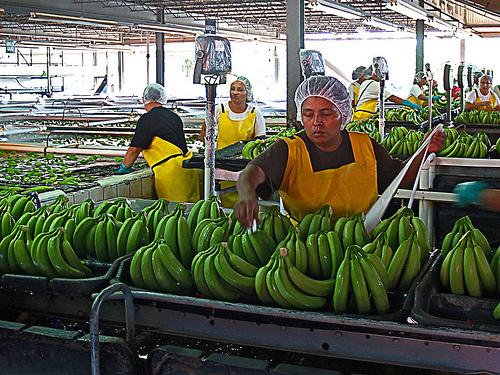Question: where was this picture taken?
Choices:
A. An apple orchard.
B. A winery.
C. A banana farm.
D. A theme park.
Answer with the letter. Answer: C Question: how do they workers keep their hair from getting on the food?
Choices:
A. Hats.
B. Shaved heads.
C. Ponytails.
D. Hair Nets.
Answer with the letter. Answer: D Question: what are these worker's doing?
Choices:
A. Picking oranges.
B. Stomping grapes.
C. Harvesting bananas.
D. Picking okra.
Answer with the letter. Answer: C Question: why are the bananas on the front stand shiny?
Choices:
A. Wet from being washed.
B. Wax.
C. Polished.
D. Water.
Answer with the letter. Answer: A Question: what color are the gloves on the worker to the furthest left?
Choices:
A. Black.
B. Red.
C. White.
D. Blue.
Answer with the letter. Answer: D 